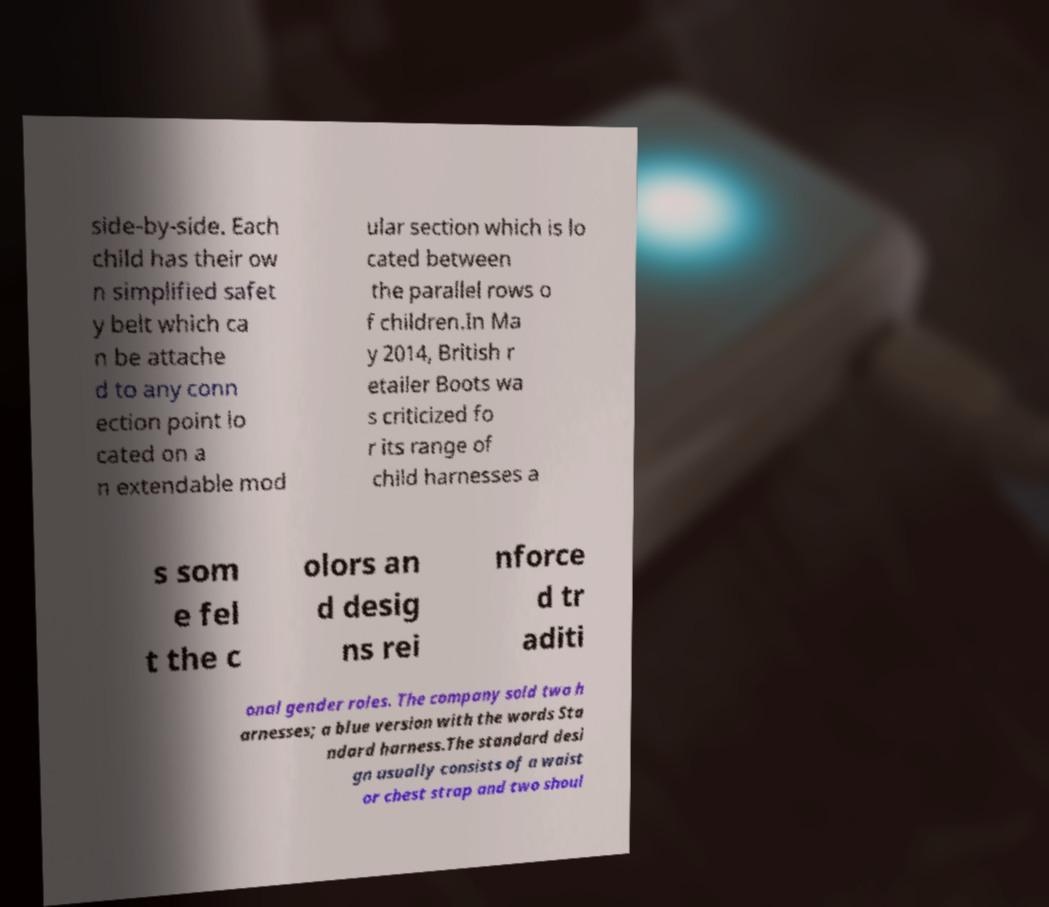What messages or text are displayed in this image? I need them in a readable, typed format. side-by-side. Each child has their ow n simplified safet y belt which ca n be attache d to any conn ection point lo cated on a n extendable mod ular section which is lo cated between the parallel rows o f children.In Ma y 2014, British r etailer Boots wa s criticized fo r its range of child harnesses a s som e fel t the c olors an d desig ns rei nforce d tr aditi onal gender roles. The company sold two h arnesses; a blue version with the words Sta ndard harness.The standard desi gn usually consists of a waist or chest strap and two shoul 